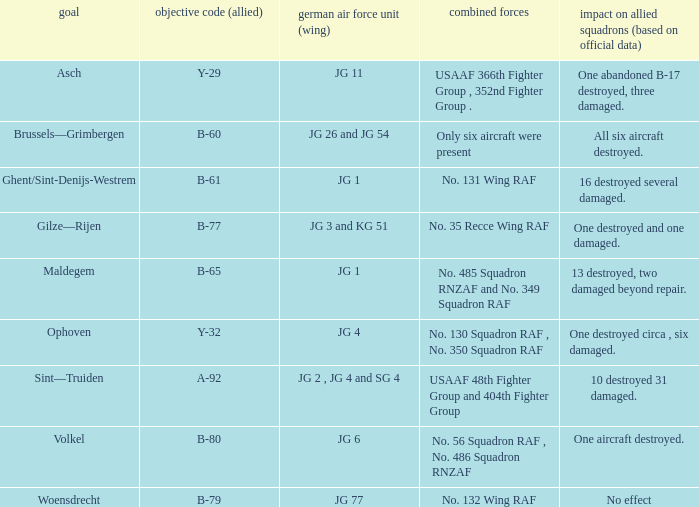Which Allied Force targetted Woensdrecht? No. 132 Wing RAF. 